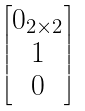Convert formula to latex. <formula><loc_0><loc_0><loc_500><loc_500>\begin{bmatrix} 0 _ { 2 \times 2 } \\ 1 \\ 0 \end{bmatrix}</formula> 